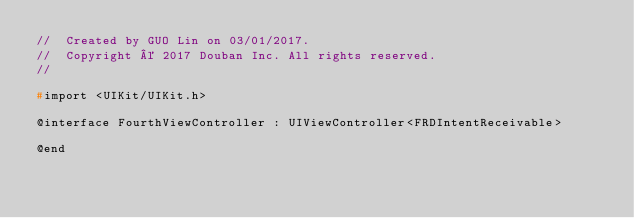Convert code to text. <code><loc_0><loc_0><loc_500><loc_500><_C_>//  Created by GUO Lin on 03/01/2017.
//  Copyright © 2017 Douban Inc. All rights reserved.
//

#import <UIKit/UIKit.h>

@interface FourthViewController : UIViewController<FRDIntentReceivable>

@end
</code> 